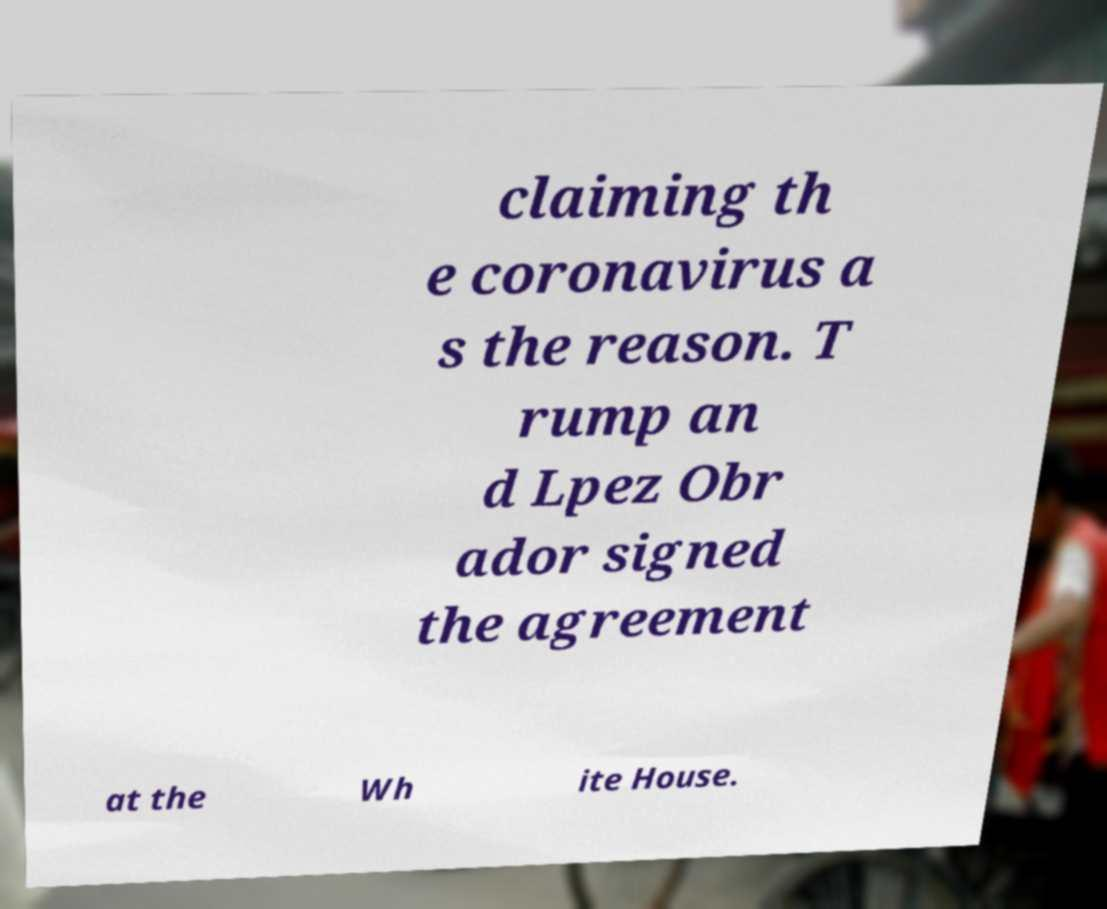There's text embedded in this image that I need extracted. Can you transcribe it verbatim? claiming th e coronavirus a s the reason. T rump an d Lpez Obr ador signed the agreement at the Wh ite House. 